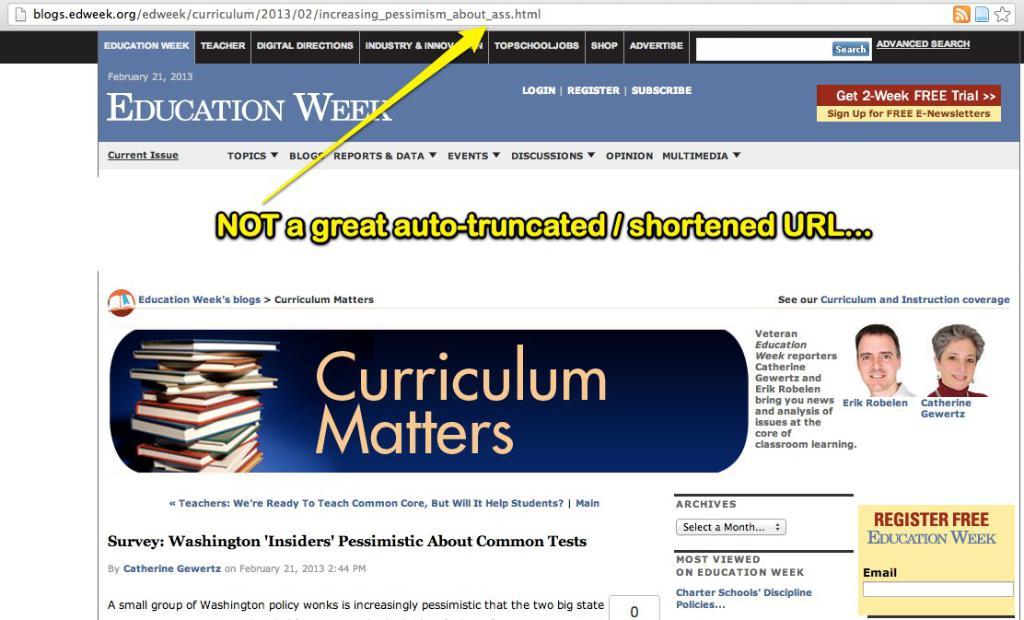What is the registration fee for this website?
Your answer should be very brief. Free. What type of "week" is shown at the top?
Give a very brief answer. Education. 